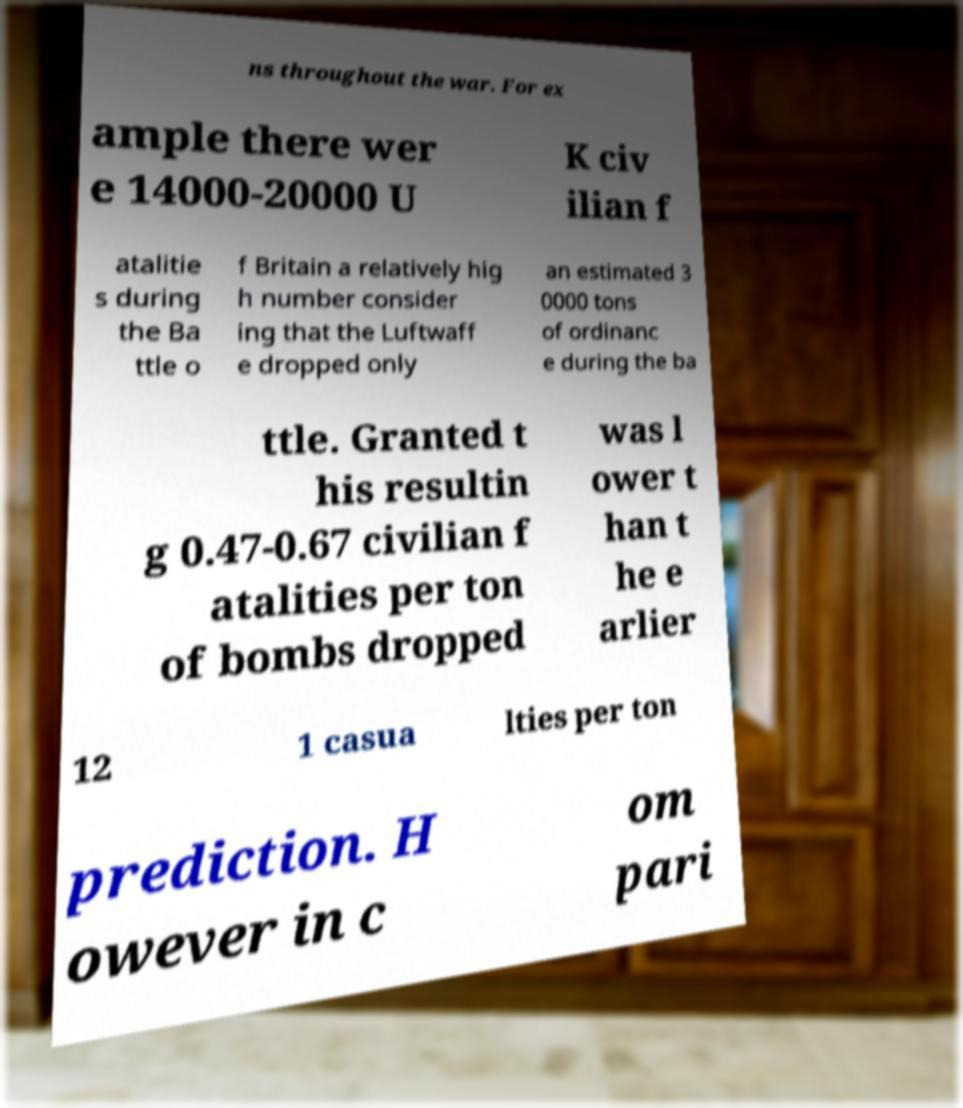Could you extract and type out the text from this image? ns throughout the war. For ex ample there wer e 14000-20000 U K civ ilian f atalitie s during the Ba ttle o f Britain a relatively hig h number consider ing that the Luftwaff e dropped only an estimated 3 0000 tons of ordinanc e during the ba ttle. Granted t his resultin g 0.47-0.67 civilian f atalities per ton of bombs dropped was l ower t han t he e arlier 12 1 casua lties per ton prediction. H owever in c om pari 